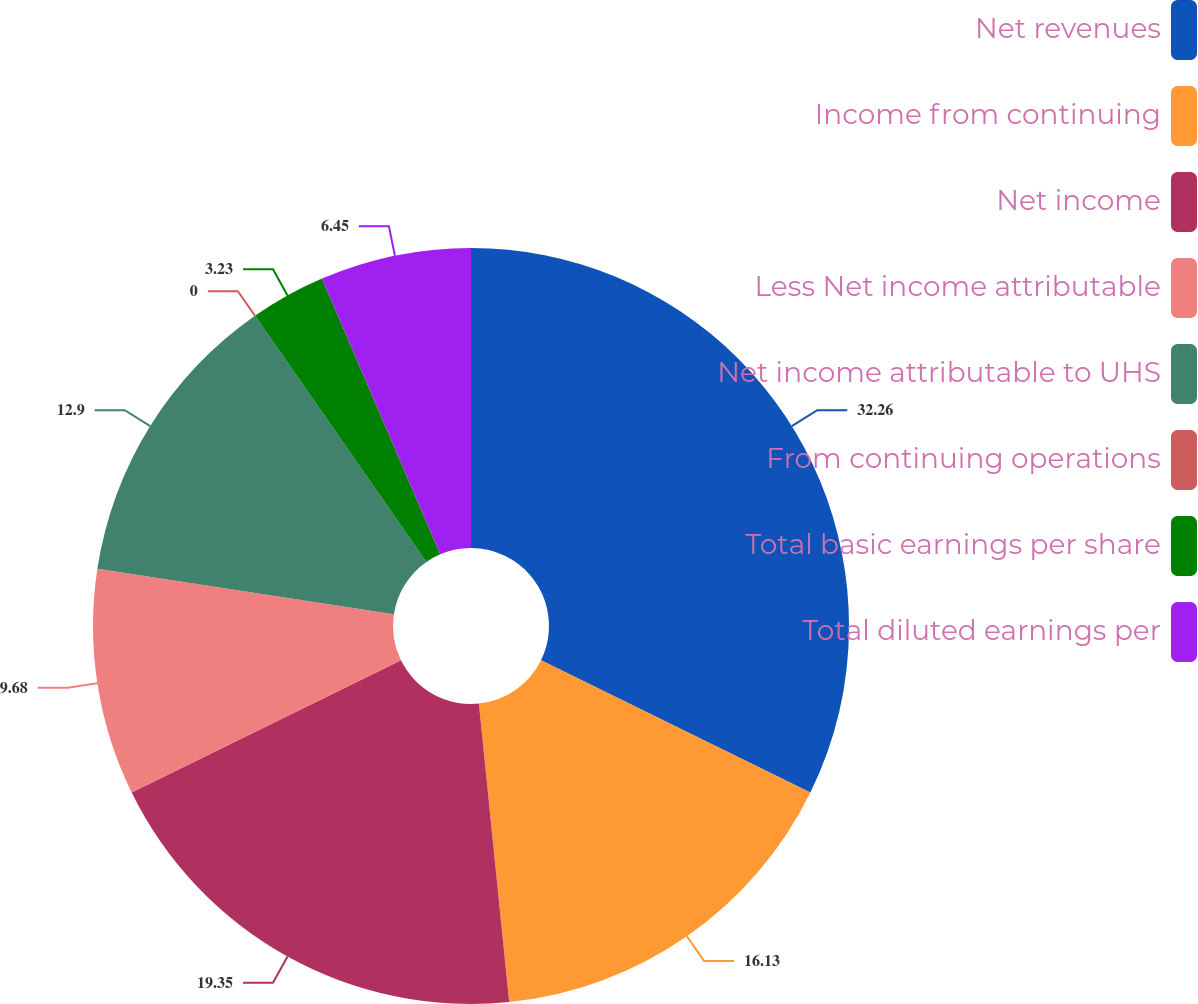<chart> <loc_0><loc_0><loc_500><loc_500><pie_chart><fcel>Net revenues<fcel>Income from continuing<fcel>Net income<fcel>Less Net income attributable<fcel>Net income attributable to UHS<fcel>From continuing operations<fcel>Total basic earnings per share<fcel>Total diluted earnings per<nl><fcel>32.26%<fcel>16.13%<fcel>19.35%<fcel>9.68%<fcel>12.9%<fcel>0.0%<fcel>3.23%<fcel>6.45%<nl></chart> 